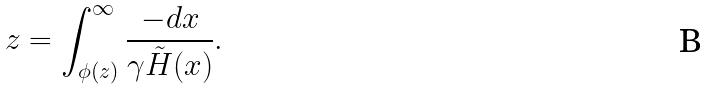Convert formula to latex. <formula><loc_0><loc_0><loc_500><loc_500>z = \int _ { \phi ( z ) } ^ { \infty } \frac { - d x } { \gamma \tilde { H } ( x ) } .</formula> 